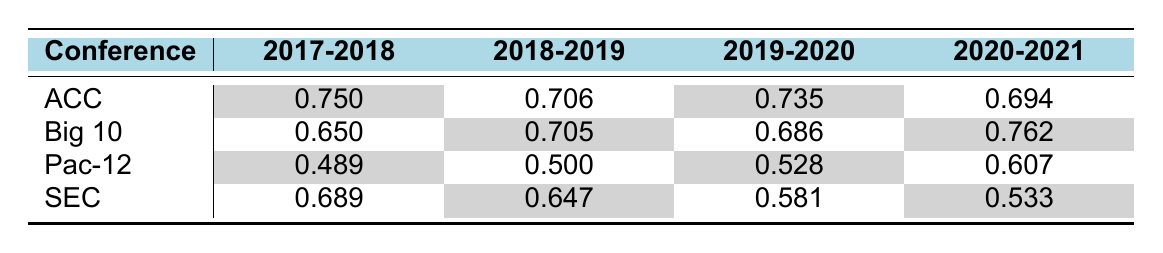What was the highest winning percentage for the Big 10 conference? The table shows that the highest winning percentage for the Big 10 is in the 2020-2021 season, where it is 0.762.
Answer: 0.762 Which conference had the lowest winning percentage in 2017-2018? According to the table, the Pac-12 conference had the lowest winning percentage in 2017-2018 at 0.489.
Answer: Pac-12 What is the average winning percentage for the SEC across the four seasons? The SEC winning percentages are 0.689, 0.647, 0.581, and 0.533. To find the average, we sum these values: 0.689 + 0.647 + 0.581 + 0.533 = 2.450. Dividing by 4 gives an average of 2.450 / 4 = 0.6125, which can be simplified to 0.613.
Answer: 0.613 Did the winning percentage for the ACC increase or decrease from 2019-2020 to 2020-2021? In 2019-2020, the ACC had a winning percentage of 0.735, and in 2020-2021, it was 0.694. Since 0.694 is lower than 0.735, this indicates a decrease in winning percentage from one season to the next.
Answer: Decrease Which conference had a winning percentage improvement over the seasons from 2017-2018 to 2020-2021? To determine this, we can compare the winning percentages: ACC (from 0.750 to 0.694) decreased, Big 10 (from 0.650 to 0.762) increased, Pac-12 (from 0.489 to 0.607) increased, and SEC (from 0.689 to 0.533) decreased. Thus, both the Big 10 and the Pac-12 showed improvement over the specified seasons.
Answer: Big 10 and Pac-12 